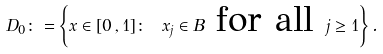Convert formula to latex. <formula><loc_0><loc_0><loc_500><loc_500>D _ { 0 } \colon = \left \{ x \in [ 0 \, , 1 ] \colon \ x _ { j } \in B \text { for all } j \geq 1 \right \} .</formula> 